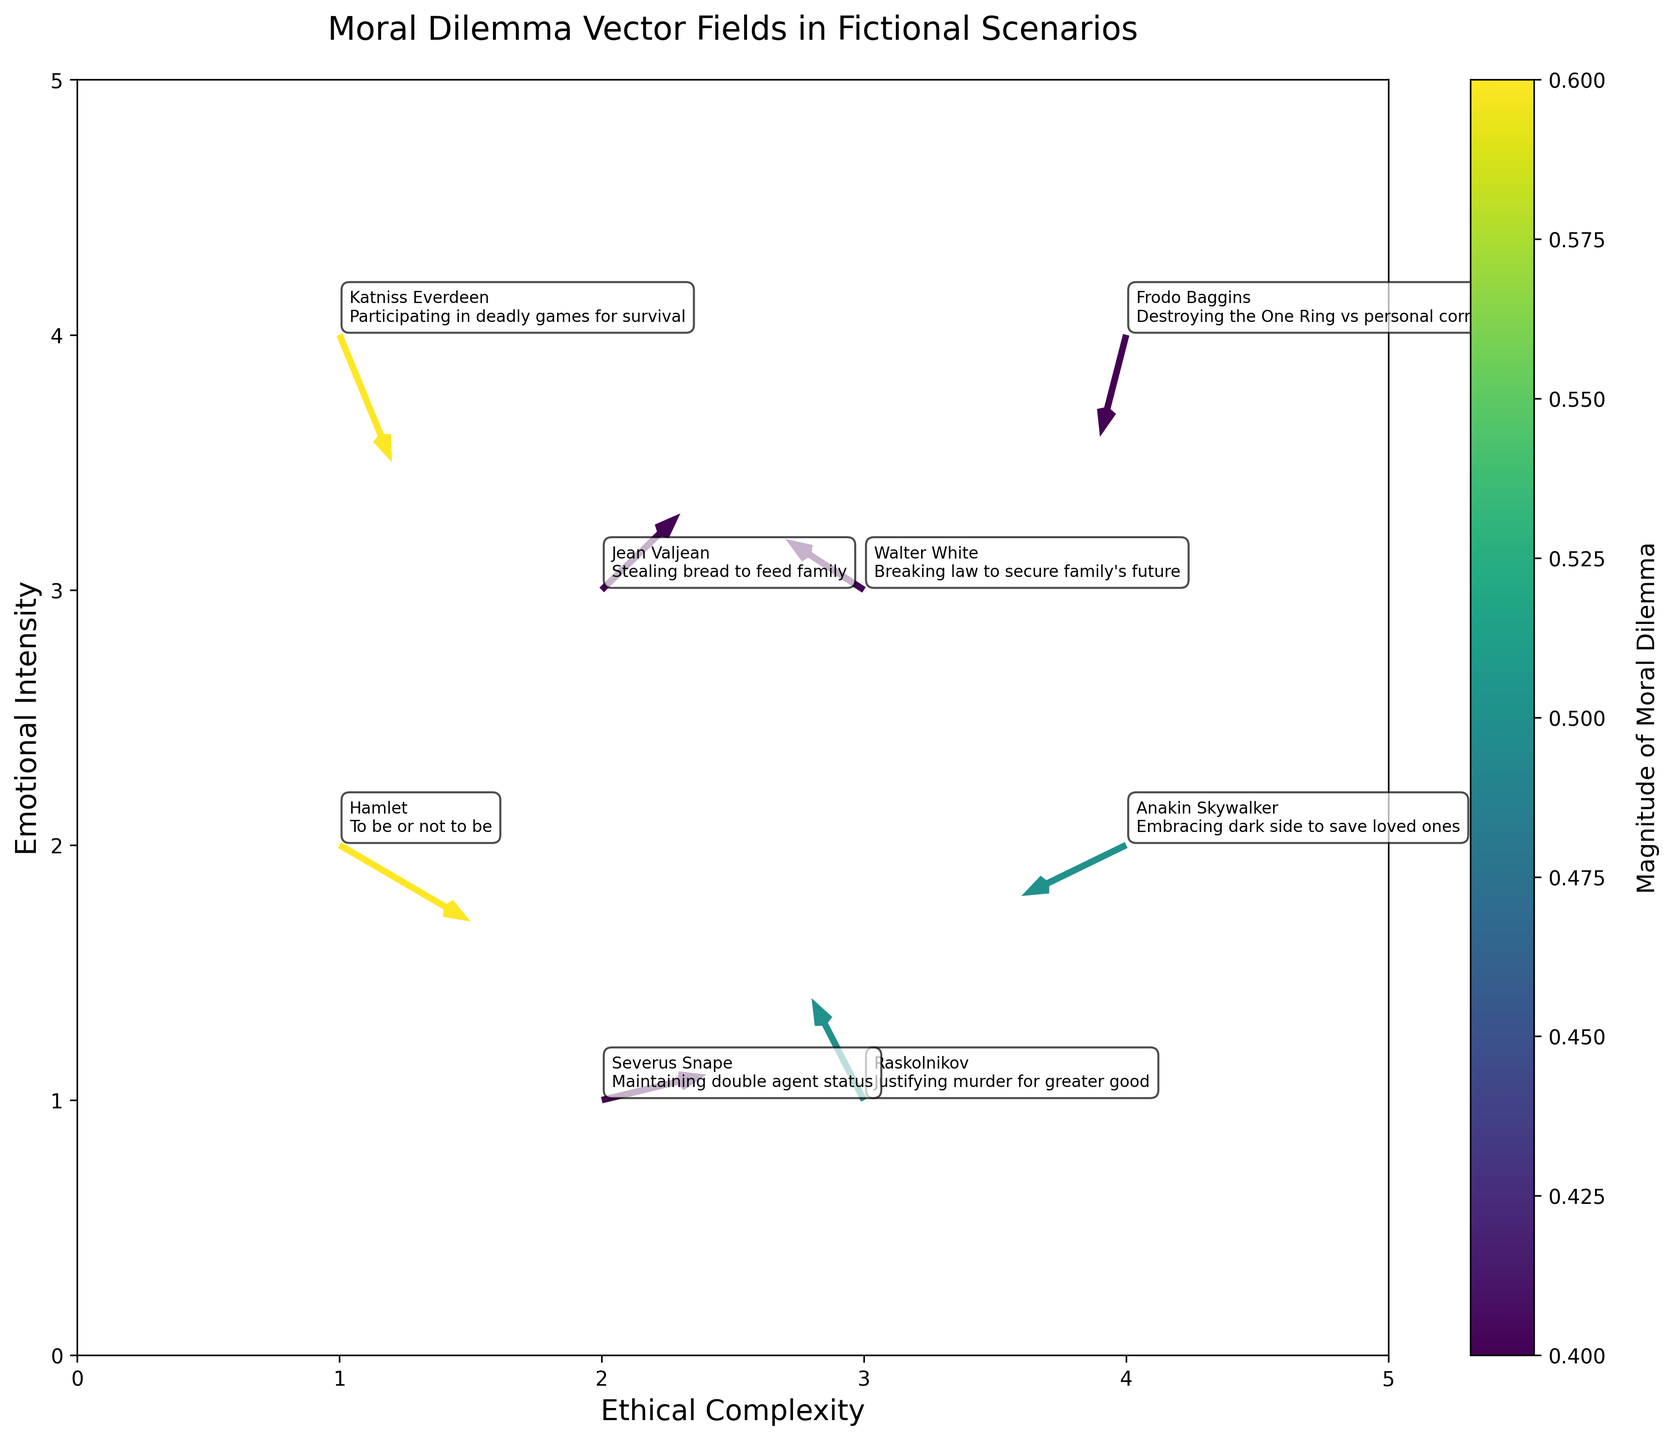what is the title of the figure? The title of the figure is typically located at the top or upper section of the plot. Reading this text gives direct insight into what the plot is about.
Answer: Moral Dilemma Vector Fields in Fictional Scenarios what are the labels of the x and y axes? The labels of the x and y axes are direct textual information found along the horizontal and vertical borders of the plot, respectively.
Answer: Ethical Complexity for x axis and Emotional Intensity for y axis which character faces the highest emotional intensity in their moral dilemma? To determine which character faces the highest emotional intensity, locate the character with the highest y-axis value.
Answer: Katniss Everdeen what is the color range indicating in the quiver plot? The color range in a quiver plot typically represents the magnitude of the vectors, which is denoted by the color bar next to the plot.
Answer: Magnitude of moral dilemma which two characters have dilemmas with a negative component value in the u-direction? To find these characters, look for vectors with a leftward (negative u-direction) arrow component. This can be identified by vectors pointing leftwards.
Answer: Raskolnikov and Anakin Skywalker how does Frodo Baggins' dilemma compare with Walter White's in terms of ethical complexity and emotional intensity? To compare, locate Frodo Baggins and Walter White on the plot, then compare their x (ethical complexity) and y (emotional intensity) coordinates. Frodo is at (4,4) and Walter is at (3,3), so Frodo’s dilemma is higher in both ethical complexity and emotional intensity.
Answer: Frodo Baggins faces higher ethical complexity and emotional intensity which character experiences the greatest overall magnitude in their moral dilemma? The greatest overall magnitude is represented by the vector with the most intense color according to the color bar. Locate this vector and identify the associated character.
Answer: Hamlet and Katniss Everdeen what type of vector field pattern is noticeable with Anakin Skywalker’s dilemma? Notice the direction and length of the vector associated with Anakin Skywalker. The vector field pattern involves a downward leftward movement indicating a complex and internally conflicting decision.
Answer: Downward leftward movement indicating internal conflict if you combine the vectors of Severus Snape and Jean Valjean, what would be the resulting direction and possible implications of this combined moral dilemma? To combine the vectors, sum the u and v components of both. Severus Snape's vector (0.4, 0.1) and Jean Valjean’s vector (0.3, 0.3) yield a resulting vector of (0.7, 0.4). This direction (upward-right) suggests a movement towards resolution with ethical gains. This implies a synergy in resolving personal and social obligations.
Answer: Upward right direction indicating a trend towards resolution how does the emotional intensity component of Severus Snape's dilemma compare to that of Jean Valjean? Compare the y-components of their vectors to see who has a higher value. Severus Snape has a y-component of 0.1 while Jean Valjean has 0.3. Thus, Jean Valjean’s emotional intensity is higher.
Answer: Jean Valjean has higher emotional intensity 